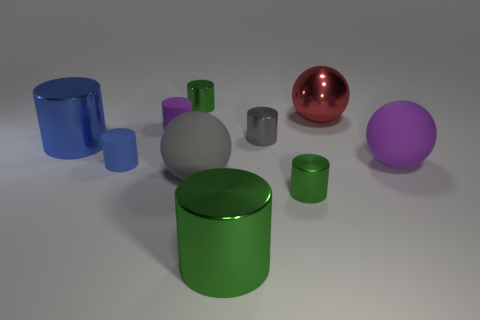Subtract all blue spheres. How many green cylinders are left? 3 Subtract all rubber balls. How many balls are left? 1 Subtract 3 cylinders. How many cylinders are left? 4 Subtract all gray cylinders. How many cylinders are left? 6 Subtract all gray cylinders. Subtract all purple cubes. How many cylinders are left? 6 Subtract all cylinders. How many objects are left? 3 Subtract 0 yellow cylinders. How many objects are left? 10 Subtract all small purple balls. Subtract all big spheres. How many objects are left? 7 Add 2 large metal cylinders. How many large metal cylinders are left? 4 Add 4 large cylinders. How many large cylinders exist? 6 